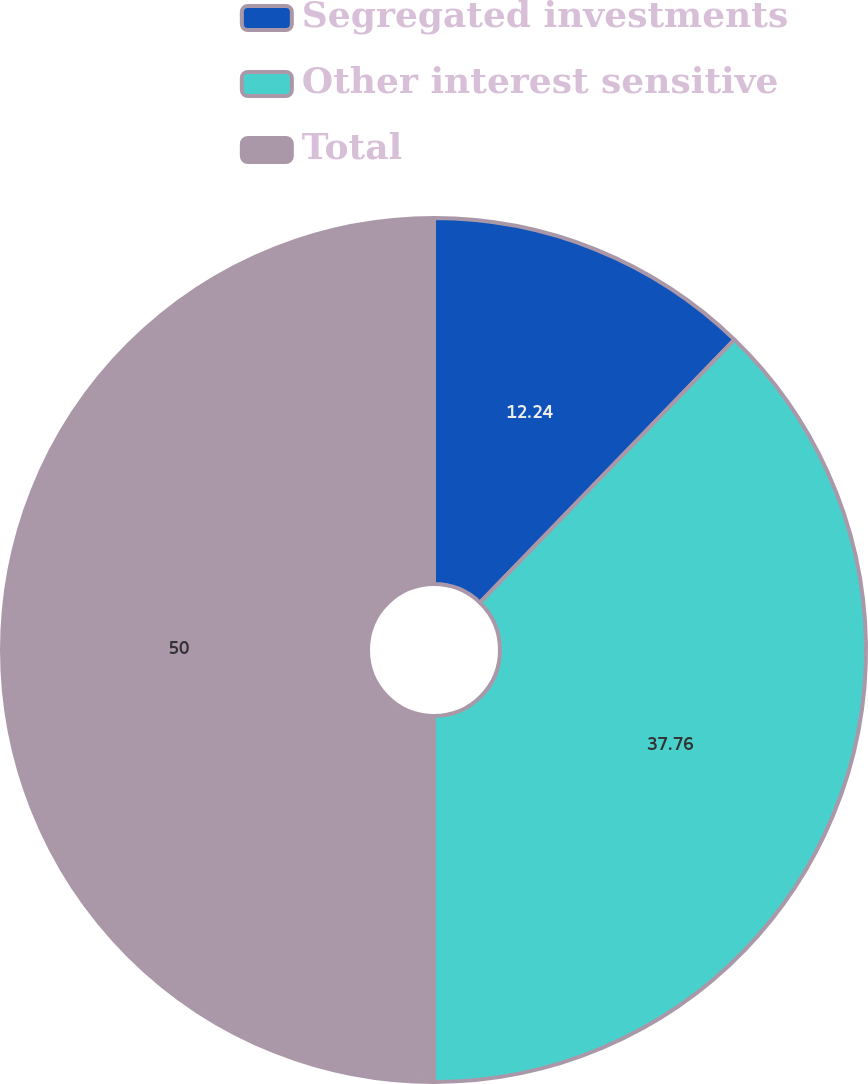Convert chart. <chart><loc_0><loc_0><loc_500><loc_500><pie_chart><fcel>Segregated investments<fcel>Other interest sensitive<fcel>Total<nl><fcel>12.24%<fcel>37.76%<fcel>50.0%<nl></chart> 